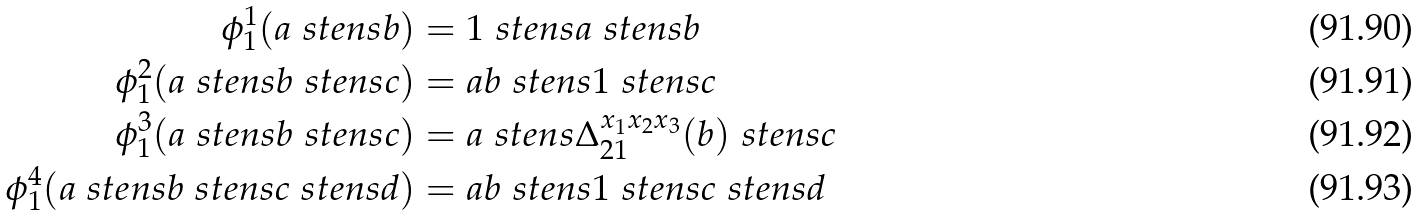<formula> <loc_0><loc_0><loc_500><loc_500>\phi _ { 1 } ^ { 1 } ( a \ s t e n s b ) & = 1 \ s t e n s a \ s t e n s b \\ \phi _ { 1 } ^ { 2 } ( a \ s t e n s b \ s t e n s c ) & = a b \ s t e n s 1 \ s t e n s c \\ \phi _ { 1 } ^ { 3 } ( a \ s t e n s b \ s t e n s c ) & = a \ s t e n s \Delta _ { 2 1 } ^ { x _ { 1 } x _ { 2 } x _ { 3 } } ( b ) \ s t e n s c \\ \phi _ { 1 } ^ { 4 } ( a \ s t e n s b \ s t e n s c \ s t e n s d ) & = a b \ s t e n s 1 \ s t e n s c \ s t e n s d</formula> 